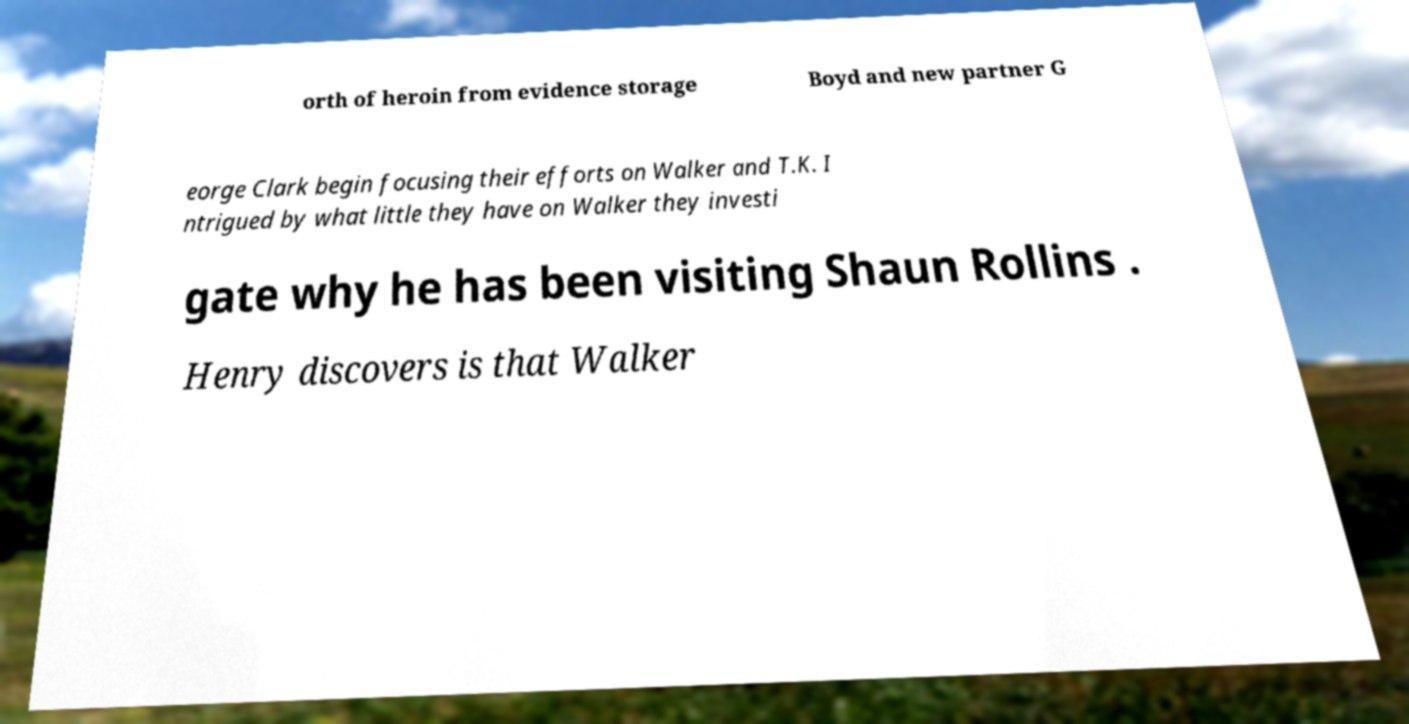Please identify and transcribe the text found in this image. orth of heroin from evidence storage Boyd and new partner G eorge Clark begin focusing their efforts on Walker and T.K. I ntrigued by what little they have on Walker they investi gate why he has been visiting Shaun Rollins . Henry discovers is that Walker 